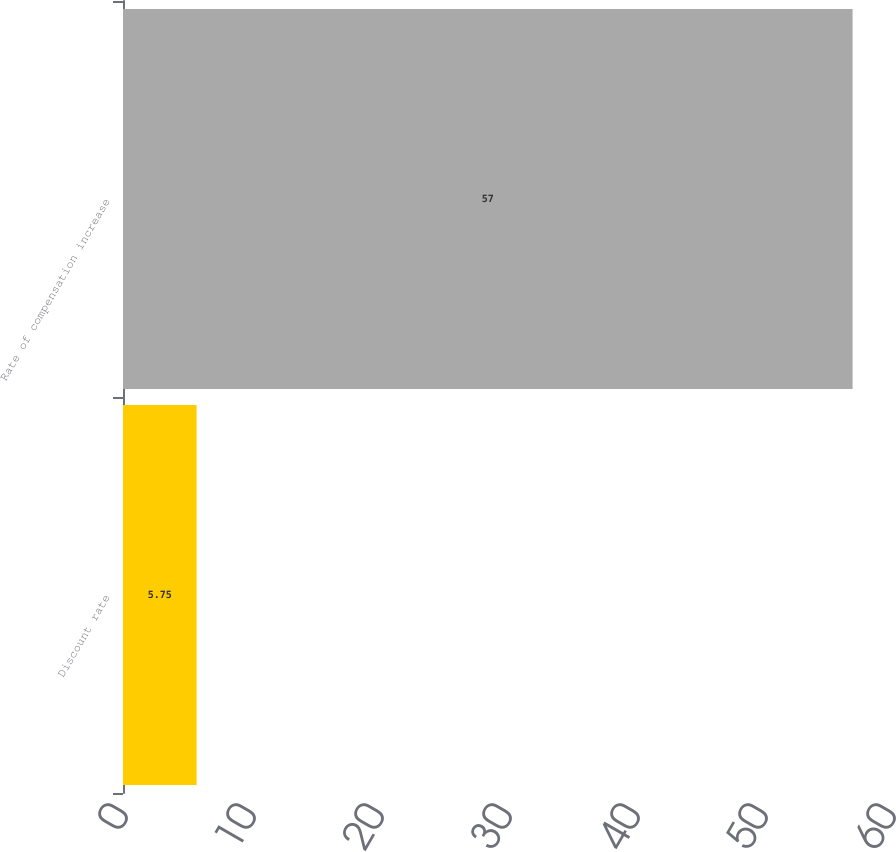Convert chart to OTSL. <chart><loc_0><loc_0><loc_500><loc_500><bar_chart><fcel>Discount rate<fcel>Rate of compensation increase<nl><fcel>5.75<fcel>57<nl></chart> 